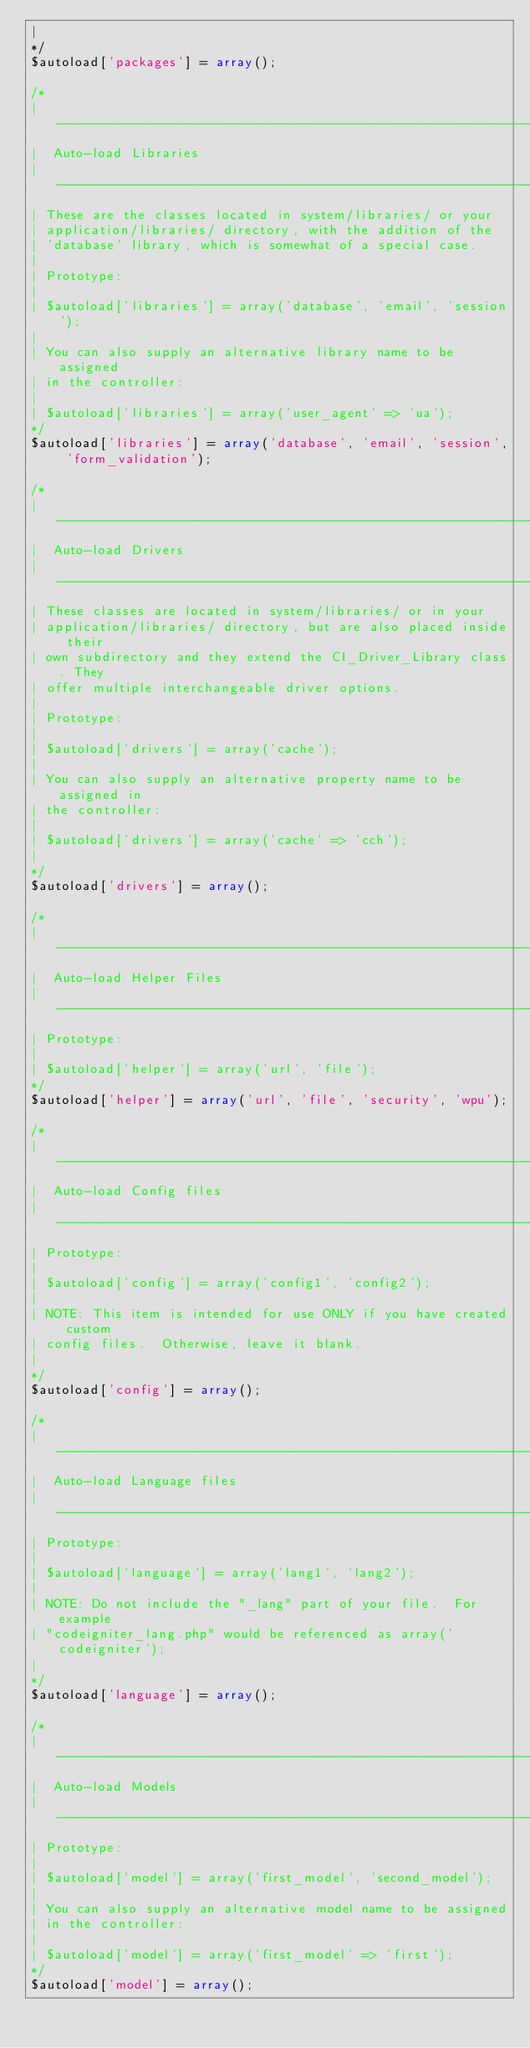Convert code to text. <code><loc_0><loc_0><loc_500><loc_500><_PHP_>|
*/
$autoload['packages'] = array();

/*
| -------------------------------------------------------------------
|  Auto-load Libraries
| -------------------------------------------------------------------
| These are the classes located in system/libraries/ or your
| application/libraries/ directory, with the addition of the
| 'database' library, which is somewhat of a special case.
|
| Prototype:
|
|	$autoload['libraries'] = array('database', 'email', 'session');
|
| You can also supply an alternative library name to be assigned
| in the controller:
|
|	$autoload['libraries'] = array('user_agent' => 'ua');
*/
$autoload['libraries'] = array('database', 'email', 'session', 'form_validation');

/*
| -------------------------------------------------------------------
|  Auto-load Drivers
| -------------------------------------------------------------------
| These classes are located in system/libraries/ or in your
| application/libraries/ directory, but are also placed inside their
| own subdirectory and they extend the CI_Driver_Library class. They
| offer multiple interchangeable driver options.
|
| Prototype:
|
|	$autoload['drivers'] = array('cache');
|
| You can also supply an alternative property name to be assigned in
| the controller:
|
|	$autoload['drivers'] = array('cache' => 'cch');
|
*/
$autoload['drivers'] = array();

/*
| -------------------------------------------------------------------
|  Auto-load Helper Files
| -------------------------------------------------------------------
| Prototype:
|
|	$autoload['helper'] = array('url', 'file');
*/
$autoload['helper'] = array('url', 'file', 'security', 'wpu');

/*
| -------------------------------------------------------------------
|  Auto-load Config files
| -------------------------------------------------------------------
| Prototype:
|
|	$autoload['config'] = array('config1', 'config2');
|
| NOTE: This item is intended for use ONLY if you have created custom
| config files.  Otherwise, leave it blank.
|
*/
$autoload['config'] = array();

/*
| -------------------------------------------------------------------
|  Auto-load Language files
| -------------------------------------------------------------------
| Prototype:
|
|	$autoload['language'] = array('lang1', 'lang2');
|
| NOTE: Do not include the "_lang" part of your file.  For example
| "codeigniter_lang.php" would be referenced as array('codeigniter');
|
*/
$autoload['language'] = array();

/*
| -------------------------------------------------------------------
|  Auto-load Models
| -------------------------------------------------------------------
| Prototype:
|
|	$autoload['model'] = array('first_model', 'second_model');
|
| You can also supply an alternative model name to be assigned
| in the controller:
|
|	$autoload['model'] = array('first_model' => 'first');
*/
$autoload['model'] = array();
</code> 